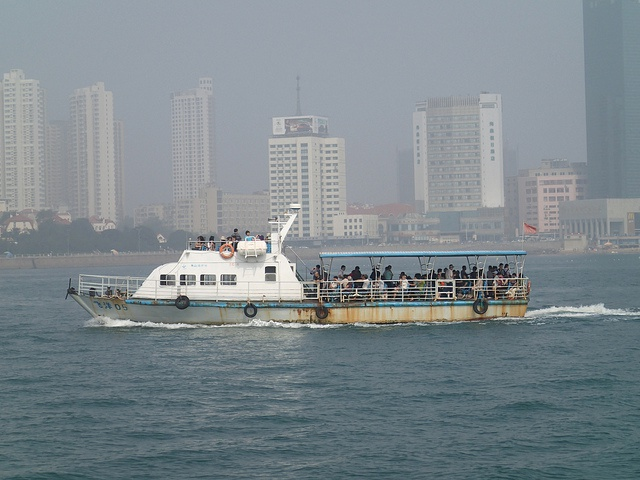Describe the objects in this image and their specific colors. I can see boat in darkgray, lightgray, gray, and black tones, people in darkgray, black, and gray tones, people in darkgray, black, gray, and darkgreen tones, people in darkgray, black, and gray tones, and people in darkgray, gray, and lightgray tones in this image. 